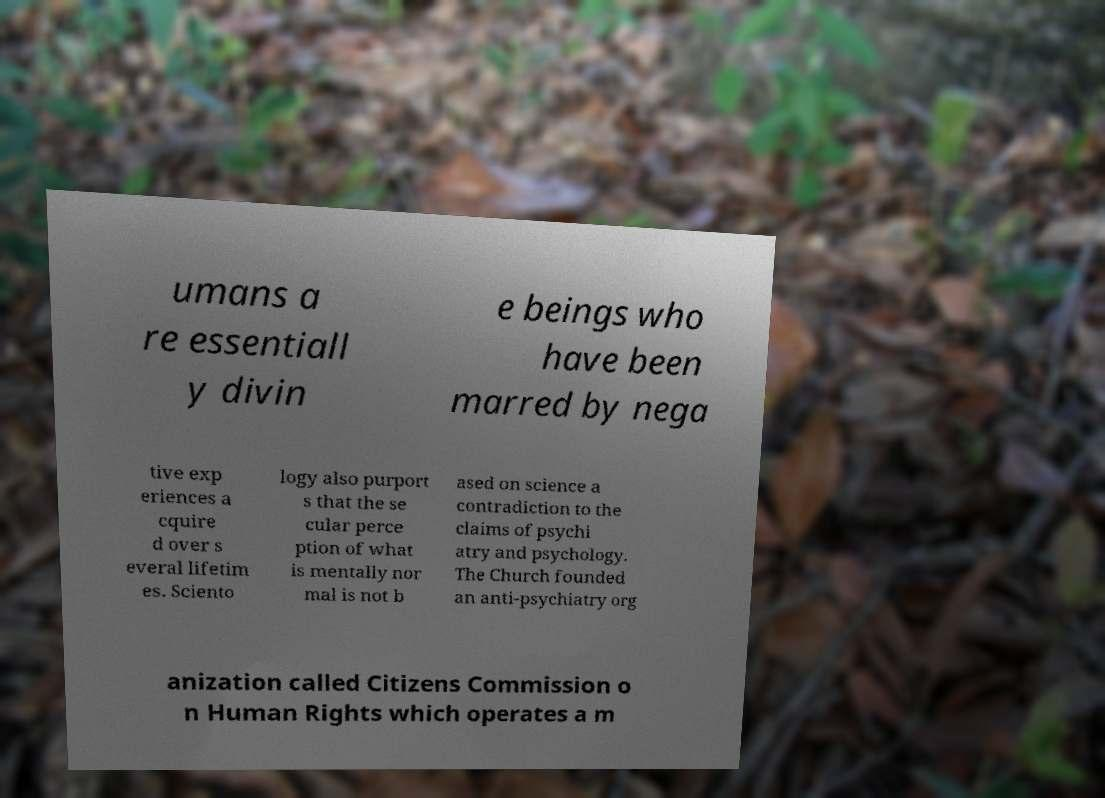Please identify and transcribe the text found in this image. umans a re essentiall y divin e beings who have been marred by nega tive exp eriences a cquire d over s everal lifetim es. Sciento logy also purport s that the se cular perce ption of what is mentally nor mal is not b ased on science a contradiction to the claims of psychi atry and psychology. The Church founded an anti-psychiatry org anization called Citizens Commission o n Human Rights which operates a m 